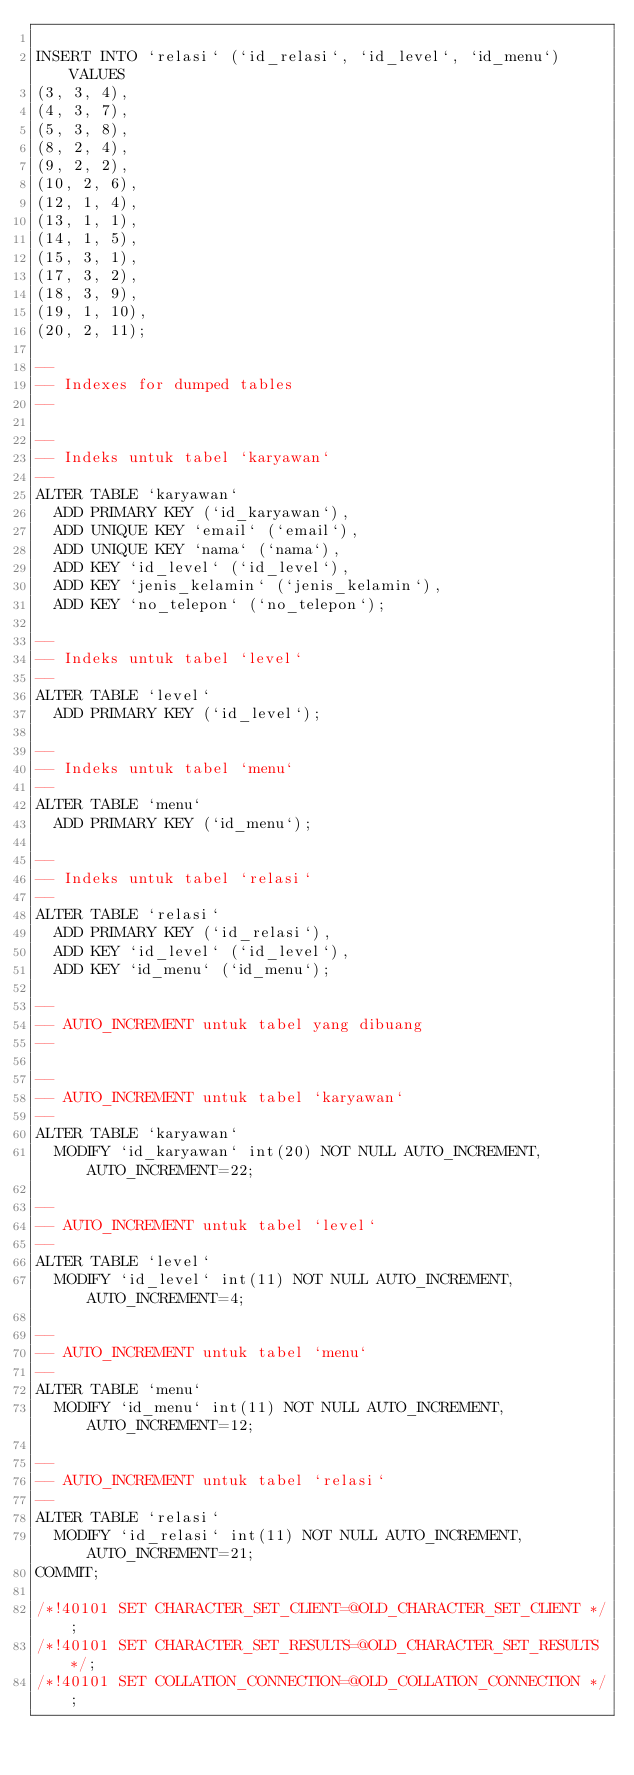<code> <loc_0><loc_0><loc_500><loc_500><_SQL_>
INSERT INTO `relasi` (`id_relasi`, `id_level`, `id_menu`) VALUES
(3, 3, 4),
(4, 3, 7),
(5, 3, 8),
(8, 2, 4),
(9, 2, 2),
(10, 2, 6),
(12, 1, 4),
(13, 1, 1),
(14, 1, 5),
(15, 3, 1),
(17, 3, 2),
(18, 3, 9),
(19, 1, 10),
(20, 2, 11);

--
-- Indexes for dumped tables
--

--
-- Indeks untuk tabel `karyawan`
--
ALTER TABLE `karyawan`
  ADD PRIMARY KEY (`id_karyawan`),
  ADD UNIQUE KEY `email` (`email`),
  ADD UNIQUE KEY `nama` (`nama`),
  ADD KEY `id_level` (`id_level`),
  ADD KEY `jenis_kelamin` (`jenis_kelamin`),
  ADD KEY `no_telepon` (`no_telepon`);

--
-- Indeks untuk tabel `level`
--
ALTER TABLE `level`
  ADD PRIMARY KEY (`id_level`);

--
-- Indeks untuk tabel `menu`
--
ALTER TABLE `menu`
  ADD PRIMARY KEY (`id_menu`);

--
-- Indeks untuk tabel `relasi`
--
ALTER TABLE `relasi`
  ADD PRIMARY KEY (`id_relasi`),
  ADD KEY `id_level` (`id_level`),
  ADD KEY `id_menu` (`id_menu`);

--
-- AUTO_INCREMENT untuk tabel yang dibuang
--

--
-- AUTO_INCREMENT untuk tabel `karyawan`
--
ALTER TABLE `karyawan`
  MODIFY `id_karyawan` int(20) NOT NULL AUTO_INCREMENT, AUTO_INCREMENT=22;

--
-- AUTO_INCREMENT untuk tabel `level`
--
ALTER TABLE `level`
  MODIFY `id_level` int(11) NOT NULL AUTO_INCREMENT, AUTO_INCREMENT=4;

--
-- AUTO_INCREMENT untuk tabel `menu`
--
ALTER TABLE `menu`
  MODIFY `id_menu` int(11) NOT NULL AUTO_INCREMENT, AUTO_INCREMENT=12;

--
-- AUTO_INCREMENT untuk tabel `relasi`
--
ALTER TABLE `relasi`
  MODIFY `id_relasi` int(11) NOT NULL AUTO_INCREMENT, AUTO_INCREMENT=21;
COMMIT;

/*!40101 SET CHARACTER_SET_CLIENT=@OLD_CHARACTER_SET_CLIENT */;
/*!40101 SET CHARACTER_SET_RESULTS=@OLD_CHARACTER_SET_RESULTS */;
/*!40101 SET COLLATION_CONNECTION=@OLD_COLLATION_CONNECTION */;
</code> 